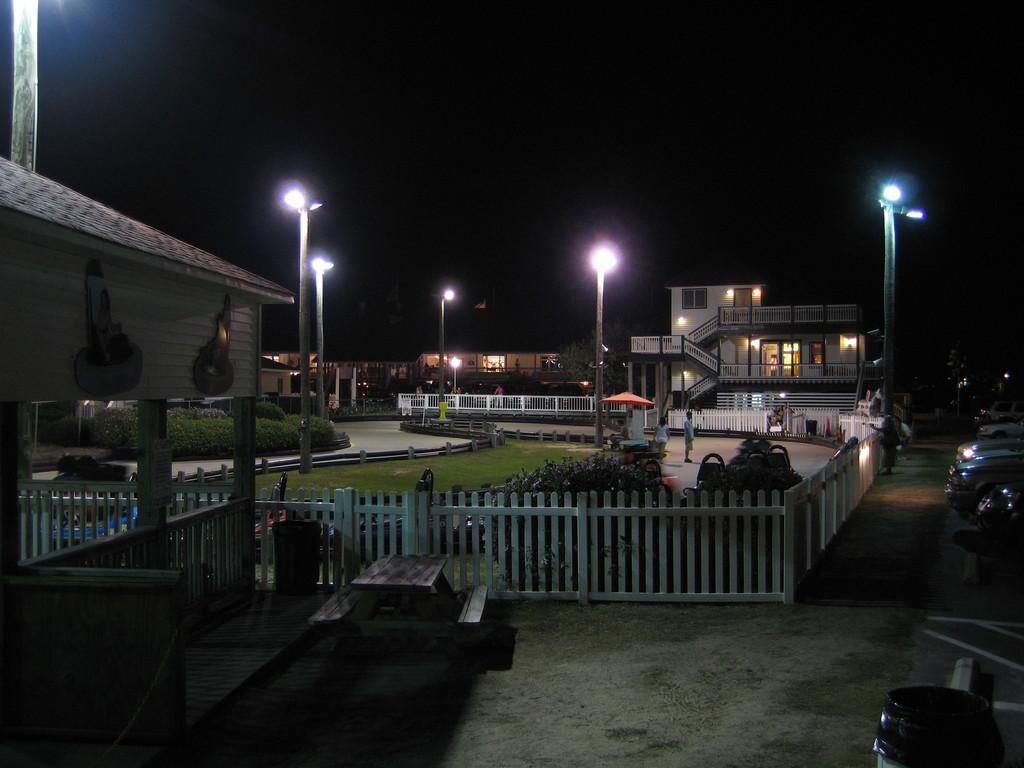How would you summarize this image in a sentence or two? This image is taken in dark where we can see wooden bench, wooden fence, wooden houses, plants, grass, light poles, people standing here, cars parked here and the dark sky in the background. 